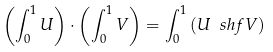<formula> <loc_0><loc_0><loc_500><loc_500>\left ( \int _ { 0 } ^ { 1 } U \right ) \cdot \left ( \int _ { 0 } ^ { 1 } V \right ) = \int _ { 0 } ^ { 1 } \left ( U \ s h f V \right )</formula> 